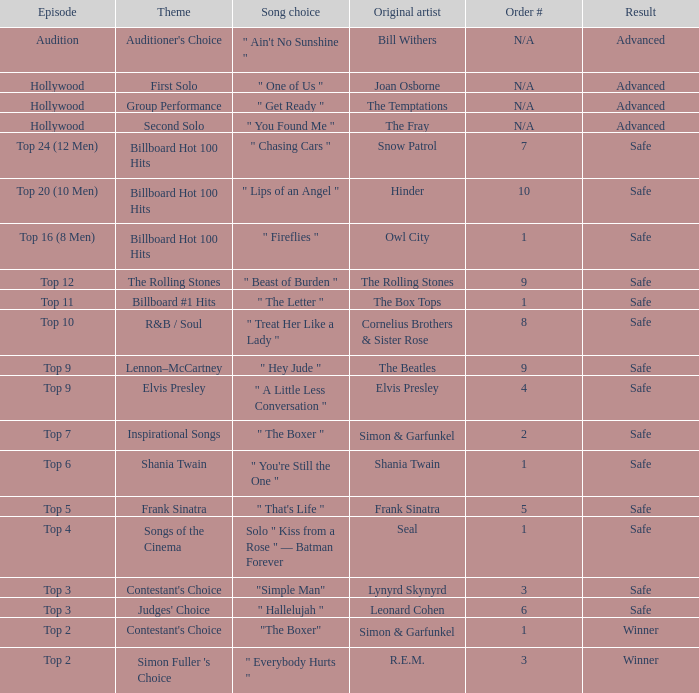The song choice " One of Us " has what themes? First Solo. 